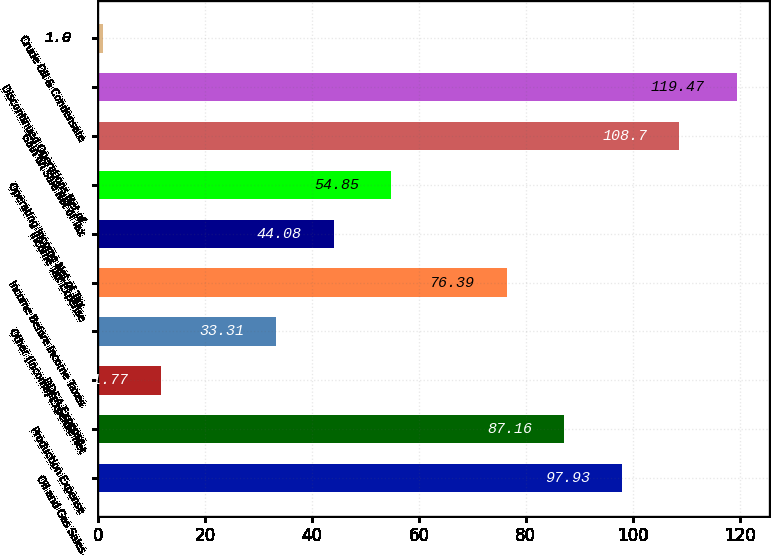Convert chart to OTSL. <chart><loc_0><loc_0><loc_500><loc_500><bar_chart><fcel>Oil and Gas Sales<fcel>Production Expense<fcel>DD&A Expense<fcel>Other (Income) Expense Net<fcel>Income Before Income Taxes<fcel>Income Tax Expense<fcel>Operating Income Net of Tax<fcel>Gain on Sale Net of Tax<fcel>Discontinued Operations Net of<fcel>Crude Oil & Condensate<nl><fcel>97.93<fcel>87.16<fcel>11.77<fcel>33.31<fcel>76.39<fcel>44.08<fcel>54.85<fcel>108.7<fcel>119.47<fcel>1<nl></chart> 